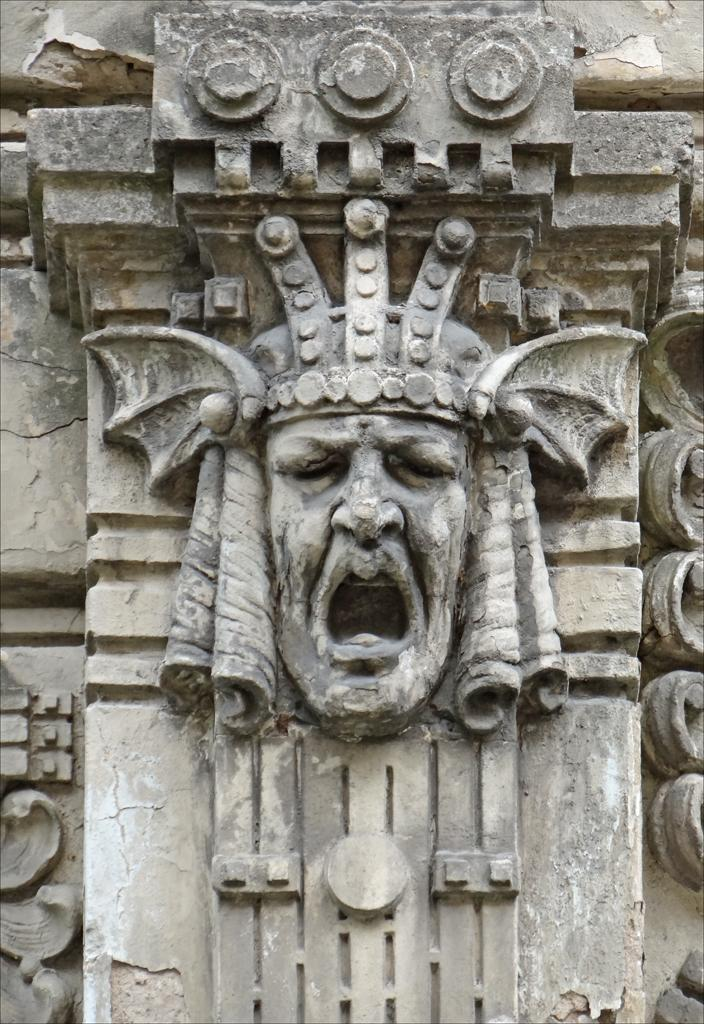What is present on the wall in the image? There is an engraving of a face on the wall. Can you describe the engraving in more detail? The engraved face is opened. What type of wish can be granted by the toad in the image? There is no toad present in the image, so it is not possible to grant any wishes. 